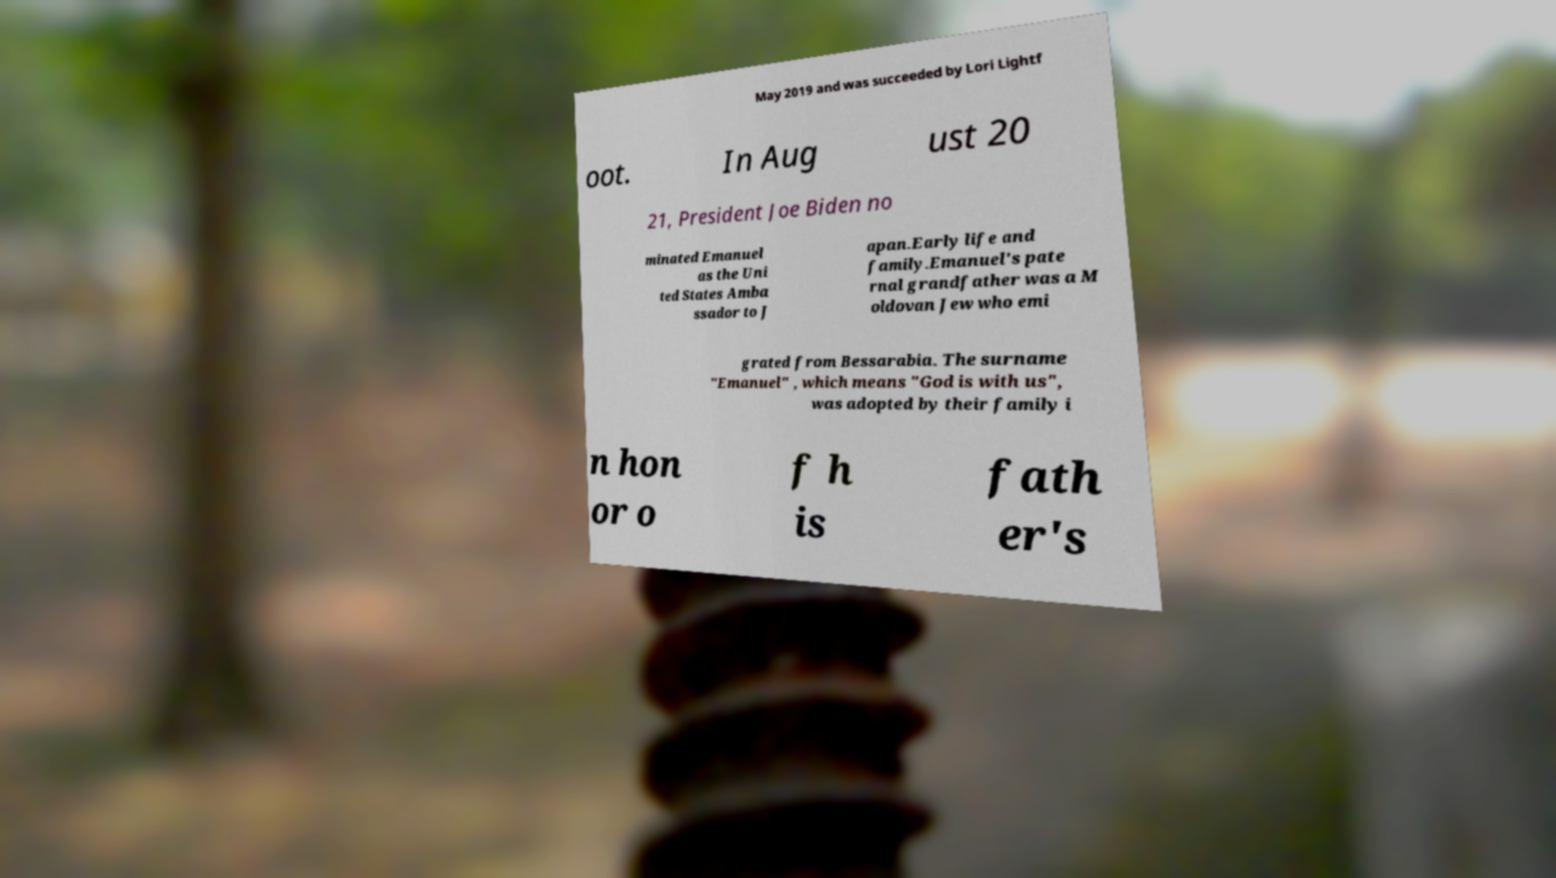I need the written content from this picture converted into text. Can you do that? May 2019 and was succeeded by Lori Lightf oot. In Aug ust 20 21, President Joe Biden no minated Emanuel as the Uni ted States Amba ssador to J apan.Early life and family.Emanuel's pate rnal grandfather was a M oldovan Jew who emi grated from Bessarabia. The surname "Emanuel" , which means "God is with us", was adopted by their family i n hon or o f h is fath er's 